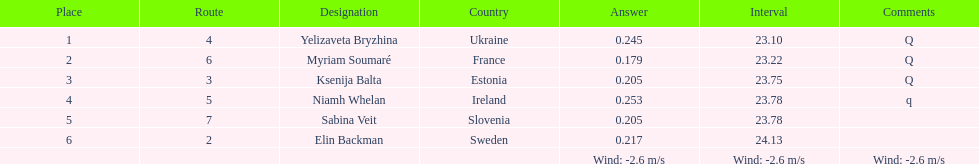Name of athlete who came in first in heat 1 of the women's 200 metres Yelizaveta Bryzhina. 